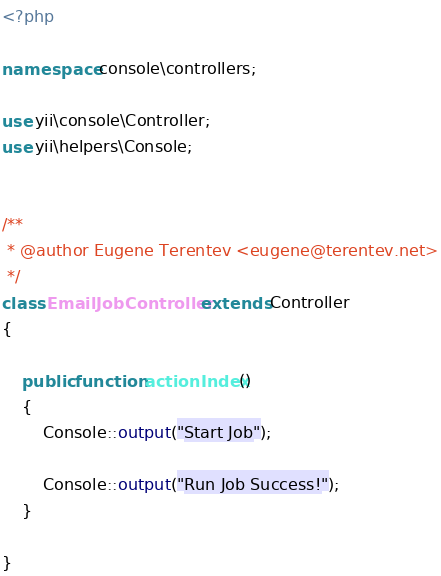Convert code to text. <code><loc_0><loc_0><loc_500><loc_500><_PHP_><?php

namespace console\controllers;

use yii\console\Controller;
use yii\helpers\Console;


/**
 * @author Eugene Terentev <eugene@terentev.net>
 */
class EmailJobController extends Controller
{

    public function actionIndex()
    {
        Console::output("Start Job");

        Console::output("Run Job Success!");
    }

}
</code> 